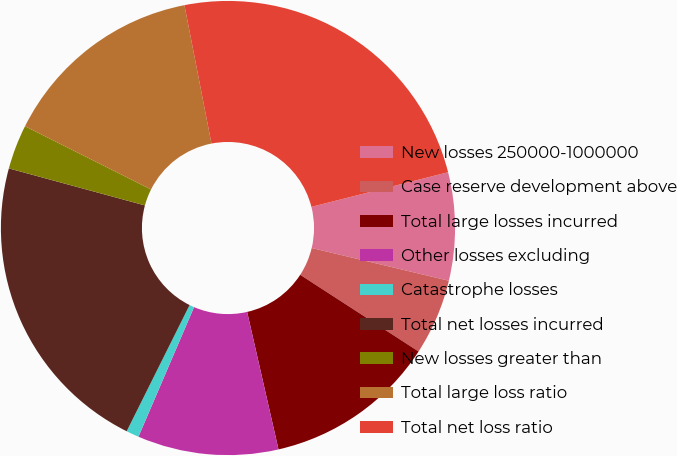Convert chart to OTSL. <chart><loc_0><loc_0><loc_500><loc_500><pie_chart><fcel>New losses 250000-1000000<fcel>Case reserve development above<fcel>Total large losses incurred<fcel>Other losses excluding<fcel>Catastrophe losses<fcel>Total net losses incurred<fcel>New losses greater than<fcel>Total large loss ratio<fcel>Total net loss ratio<nl><fcel>7.68%<fcel>5.42%<fcel>12.28%<fcel>10.02%<fcel>0.91%<fcel>21.87%<fcel>3.17%<fcel>14.53%<fcel>24.12%<nl></chart> 